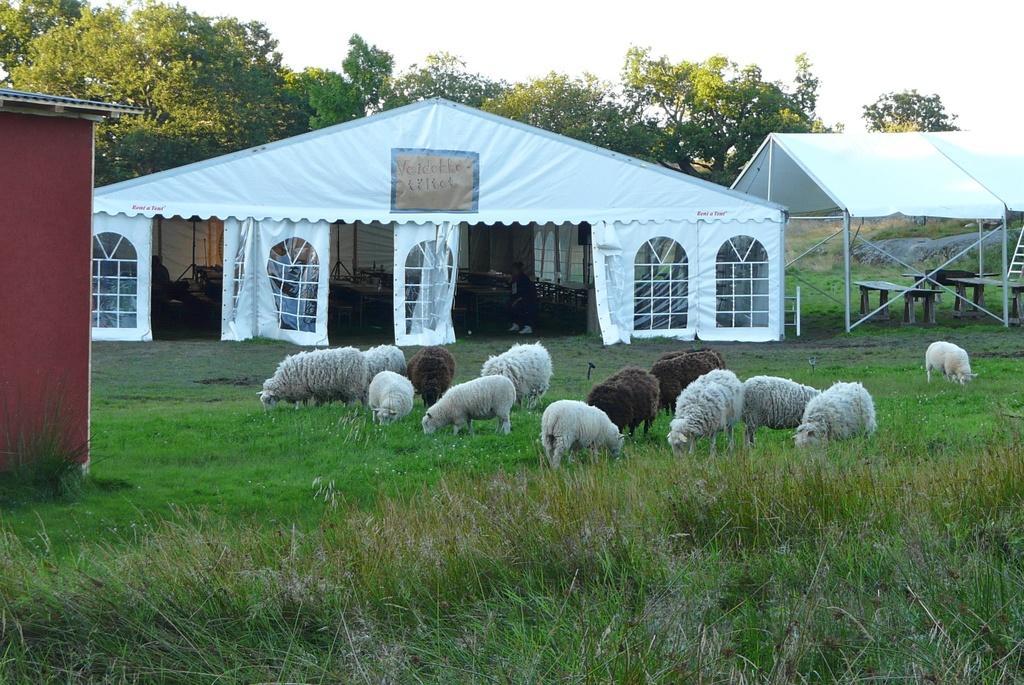Can you describe this image briefly? In this picture I can see sheeps, there is grass, there are tables, tents, there are trees, and in the background there is sky. 